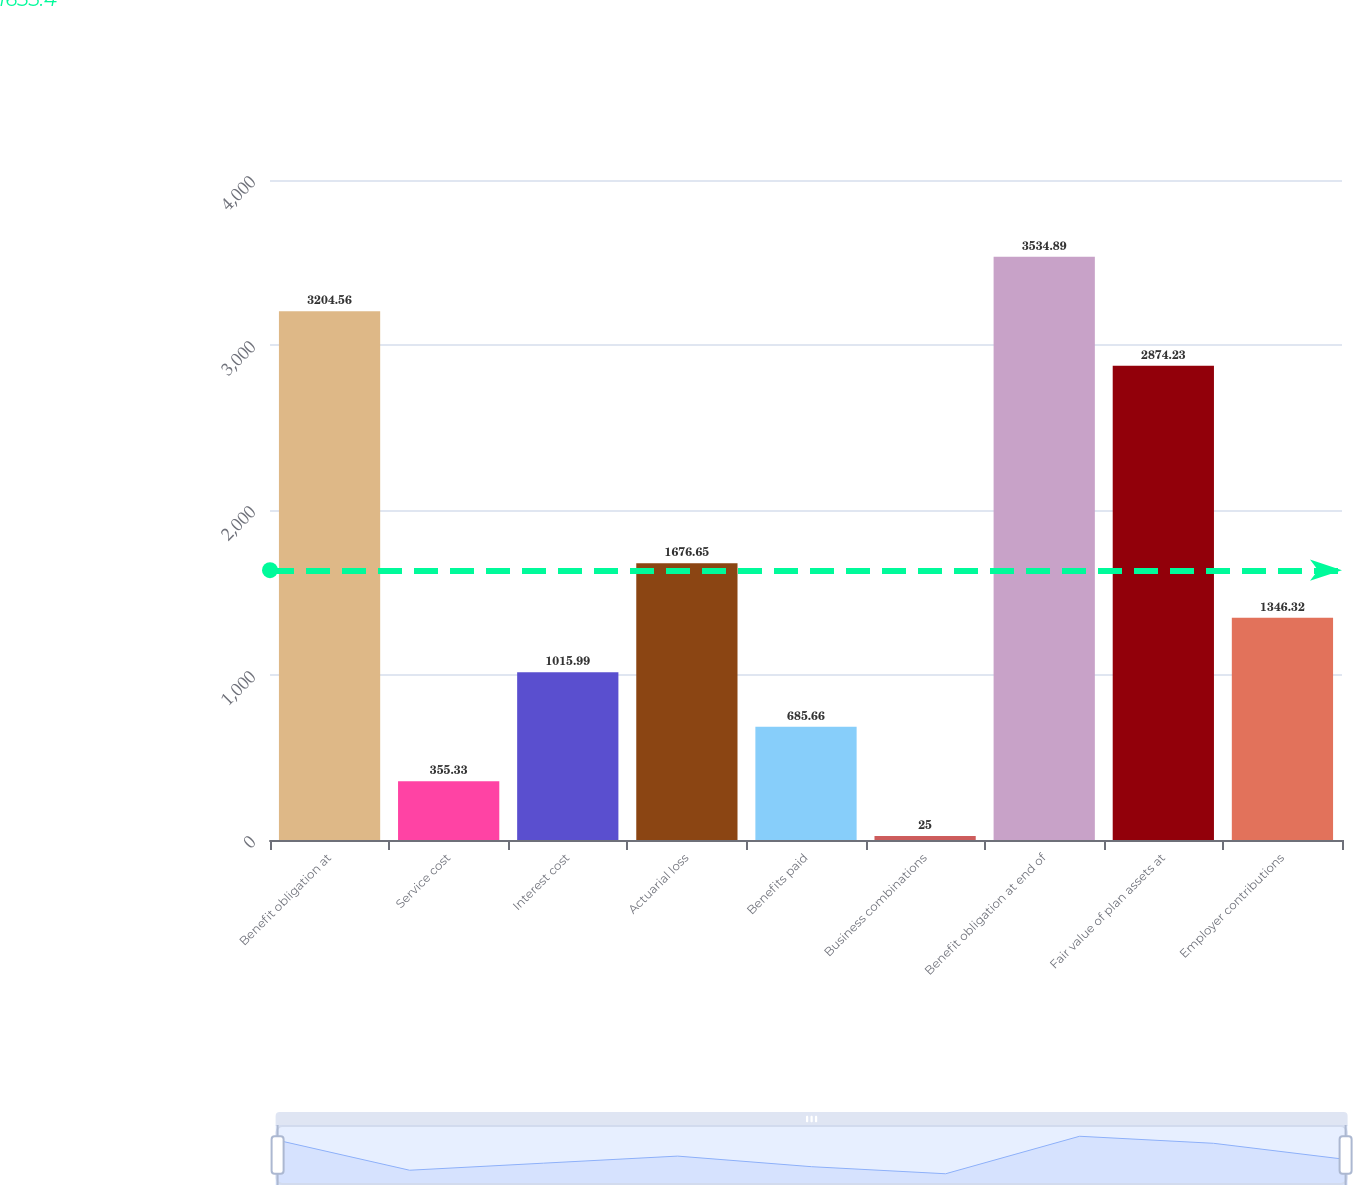Convert chart. <chart><loc_0><loc_0><loc_500><loc_500><bar_chart><fcel>Benefit obligation at<fcel>Service cost<fcel>Interest cost<fcel>Actuarial loss<fcel>Benefits paid<fcel>Business combinations<fcel>Benefit obligation at end of<fcel>Fair value of plan assets at<fcel>Employer contributions<nl><fcel>3204.56<fcel>355.33<fcel>1015.99<fcel>1676.65<fcel>685.66<fcel>25<fcel>3534.89<fcel>2874.23<fcel>1346.32<nl></chart> 